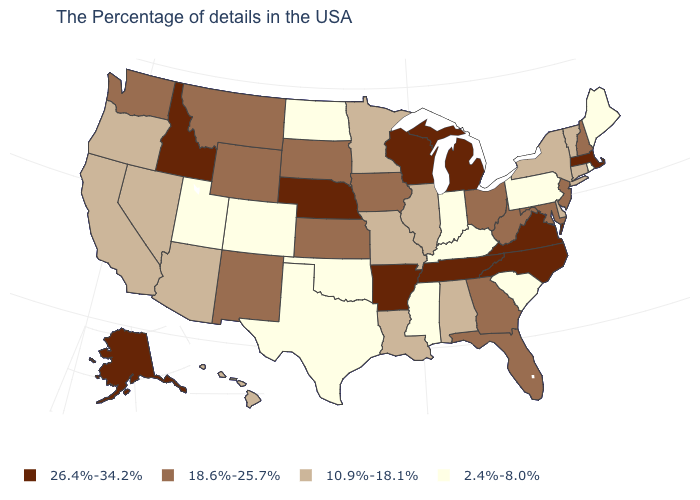What is the lowest value in the West?
Write a very short answer. 2.4%-8.0%. What is the value of New Hampshire?
Quick response, please. 18.6%-25.7%. What is the highest value in the USA?
Short answer required. 26.4%-34.2%. What is the value of Massachusetts?
Be succinct. 26.4%-34.2%. Name the states that have a value in the range 10.9%-18.1%?
Concise answer only. Vermont, Connecticut, New York, Delaware, Alabama, Illinois, Louisiana, Missouri, Minnesota, Arizona, Nevada, California, Oregon, Hawaii. What is the value of Minnesota?
Short answer required. 10.9%-18.1%. What is the value of Nebraska?
Be succinct. 26.4%-34.2%. Which states hav the highest value in the South?
Answer briefly. Virginia, North Carolina, Tennessee, Arkansas. Does West Virginia have a higher value than Utah?
Short answer required. Yes. Which states have the lowest value in the USA?
Be succinct. Maine, Rhode Island, Pennsylvania, South Carolina, Kentucky, Indiana, Mississippi, Oklahoma, Texas, North Dakota, Colorado, Utah. What is the value of Connecticut?
Quick response, please. 10.9%-18.1%. What is the highest value in states that border Missouri?
Write a very short answer. 26.4%-34.2%. What is the highest value in states that border Florida?
Give a very brief answer. 18.6%-25.7%. Which states have the lowest value in the MidWest?
Answer briefly. Indiana, North Dakota. What is the value of Louisiana?
Write a very short answer. 10.9%-18.1%. 